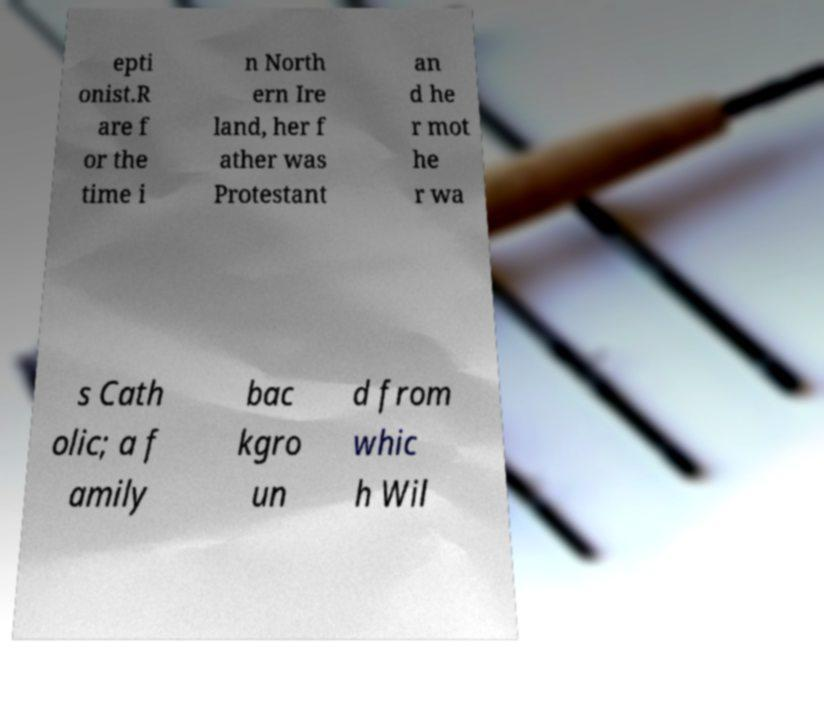What messages or text are displayed in this image? I need them in a readable, typed format. epti onist.R are f or the time i n North ern Ire land, her f ather was Protestant an d he r mot he r wa s Cath olic; a f amily bac kgro un d from whic h Wil 